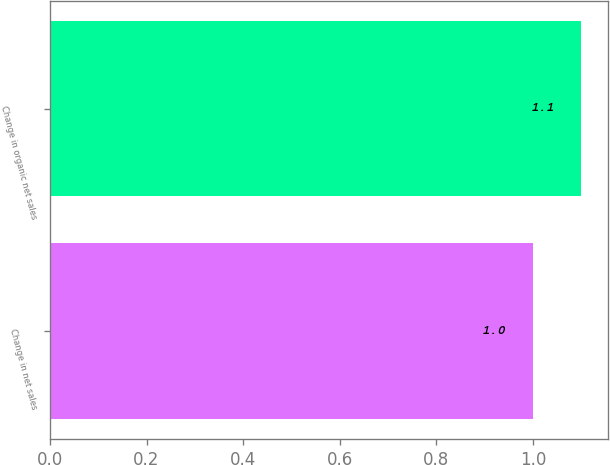Convert chart. <chart><loc_0><loc_0><loc_500><loc_500><bar_chart><fcel>Change in net sales<fcel>Change in organic net sales<nl><fcel>1<fcel>1.1<nl></chart> 